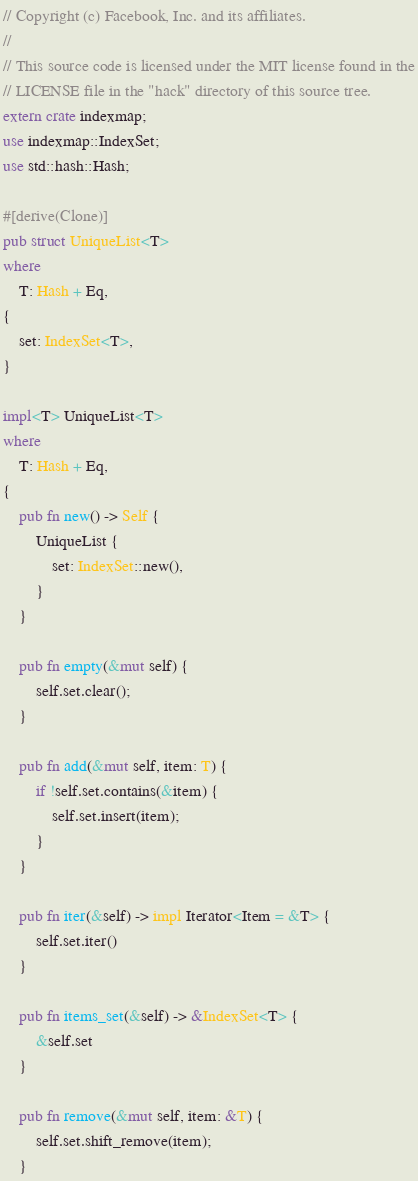<code> <loc_0><loc_0><loc_500><loc_500><_Rust_>// Copyright (c) Facebook, Inc. and its affiliates.
//
// This source code is licensed under the MIT license found in the
// LICENSE file in the "hack" directory of this source tree.
extern crate indexmap;
use indexmap::IndexSet;
use std::hash::Hash;

#[derive(Clone)]
pub struct UniqueList<T>
where
    T: Hash + Eq,
{
    set: IndexSet<T>,
}

impl<T> UniqueList<T>
where
    T: Hash + Eq,
{
    pub fn new() -> Self {
        UniqueList {
            set: IndexSet::new(),
        }
    }

    pub fn empty(&mut self) {
        self.set.clear();
    }

    pub fn add(&mut self, item: T) {
        if !self.set.contains(&item) {
            self.set.insert(item);
        }
    }

    pub fn iter(&self) -> impl Iterator<Item = &T> {
        self.set.iter()
    }

    pub fn items_set(&self) -> &IndexSet<T> {
        &self.set
    }

    pub fn remove(&mut self, item: &T) {
        self.set.shift_remove(item);
    }
</code> 